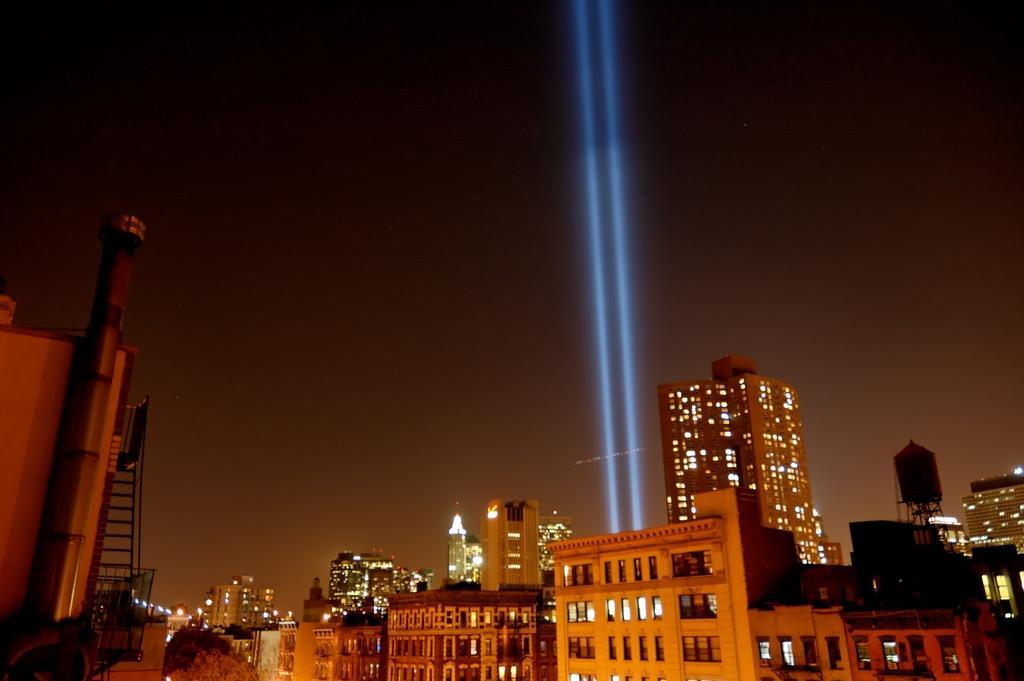Could you give a brief overview of what you see in this image? There are some buildings at the bottom of this image and there is a light focus as we can see in the middle of this image, and there is a sky in the background. 